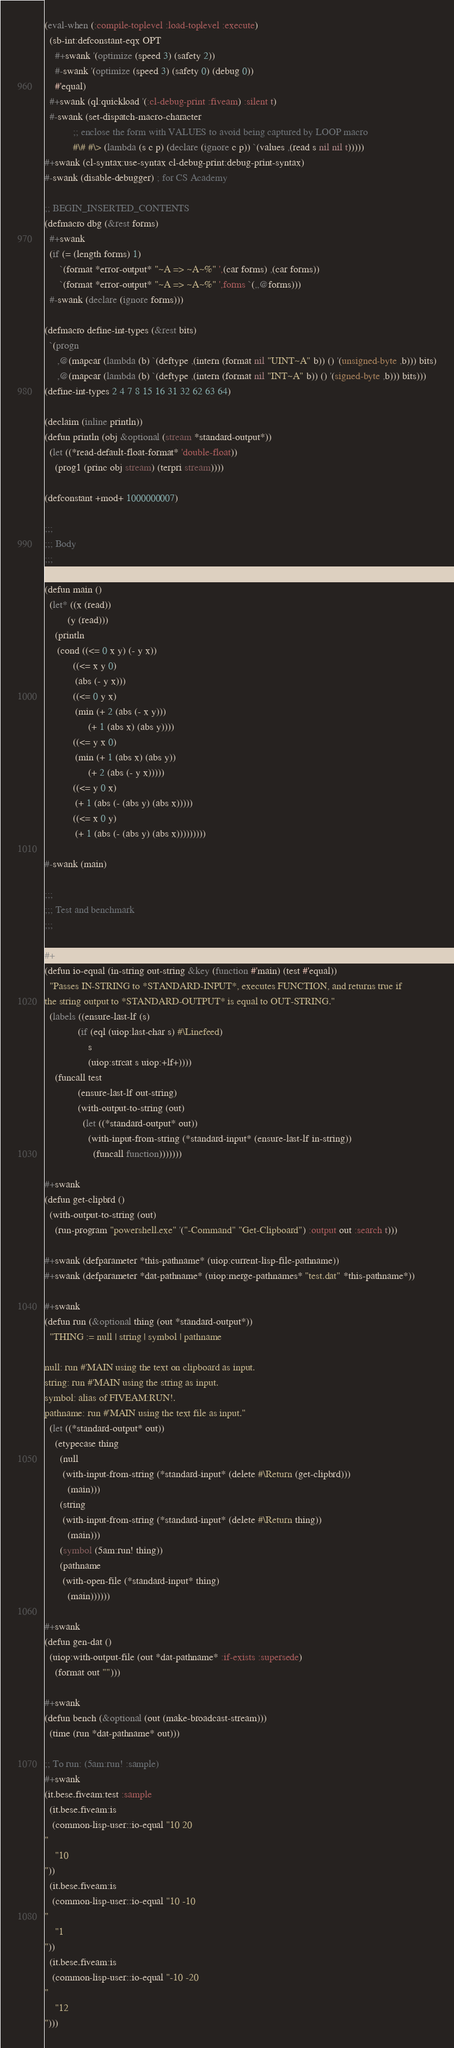<code> <loc_0><loc_0><loc_500><loc_500><_Lisp_>(eval-when (:compile-toplevel :load-toplevel :execute)
  (sb-int:defconstant-eqx OPT
    #+swank '(optimize (speed 3) (safety 2))
    #-swank '(optimize (speed 3) (safety 0) (debug 0))
    #'equal)
  #+swank (ql:quickload '(:cl-debug-print :fiveam) :silent t)
  #-swank (set-dispatch-macro-character
           ;; enclose the form with VALUES to avoid being captured by LOOP macro
           #\# #\> (lambda (s c p) (declare (ignore c p)) `(values ,(read s nil nil t)))))
#+swank (cl-syntax:use-syntax cl-debug-print:debug-print-syntax)
#-swank (disable-debugger) ; for CS Academy

;; BEGIN_INSERTED_CONTENTS
(defmacro dbg (&rest forms)
  #+swank
  (if (= (length forms) 1)
      `(format *error-output* "~A => ~A~%" ',(car forms) ,(car forms))
      `(format *error-output* "~A => ~A~%" ',forms `(,,@forms)))
  #-swank (declare (ignore forms)))

(defmacro define-int-types (&rest bits)
  `(progn
     ,@(mapcar (lambda (b) `(deftype ,(intern (format nil "UINT~A" b)) () '(unsigned-byte ,b))) bits)
     ,@(mapcar (lambda (b) `(deftype ,(intern (format nil "INT~A" b)) () '(signed-byte ,b))) bits)))
(define-int-types 2 4 7 8 15 16 31 32 62 63 64)

(declaim (inline println))
(defun println (obj &optional (stream *standard-output*))
  (let ((*read-default-float-format* 'double-float))
    (prog1 (princ obj stream) (terpri stream))))

(defconstant +mod+ 1000000007)

;;;
;;; Body
;;;

(defun main ()
  (let* ((x (read))
         (y (read)))
    (println
     (cond ((<= 0 x y) (- y x))
           ((<= x y 0)
            (abs (- y x)))
           ((<= 0 y x)
            (min (+ 2 (abs (- x y)))
                 (+ 1 (abs x) (abs y))))
           ((<= y x 0)
            (min (+ 1 (abs x) (abs y))
                 (+ 2 (abs (- y x)))))
           ((<= y 0 x)
            (+ 1 (abs (- (abs y) (abs x)))))
           ((<= x 0 y)
            (+ 1 (abs (- (abs y) (abs x)))))))))

#-swank (main)

;;;
;;; Test and benchmark
;;;

#+swank
(defun io-equal (in-string out-string &key (function #'main) (test #'equal))
  "Passes IN-STRING to *STANDARD-INPUT*, executes FUNCTION, and returns true if
the string output to *STANDARD-OUTPUT* is equal to OUT-STRING."
  (labels ((ensure-last-lf (s)
             (if (eql (uiop:last-char s) #\Linefeed)
                 s
                 (uiop:strcat s uiop:+lf+))))
    (funcall test
             (ensure-last-lf out-string)
             (with-output-to-string (out)
               (let ((*standard-output* out))
                 (with-input-from-string (*standard-input* (ensure-last-lf in-string))
                   (funcall function)))))))

#+swank
(defun get-clipbrd ()
  (with-output-to-string (out)
    (run-program "powershell.exe" '("-Command" "Get-Clipboard") :output out :search t)))

#+swank (defparameter *this-pathname* (uiop:current-lisp-file-pathname))
#+swank (defparameter *dat-pathname* (uiop:merge-pathnames* "test.dat" *this-pathname*))

#+swank
(defun run (&optional thing (out *standard-output*))
  "THING := null | string | symbol | pathname

null: run #'MAIN using the text on clipboard as input.
string: run #'MAIN using the string as input.
symbol: alias of FIVEAM:RUN!.
pathname: run #'MAIN using the text file as input."
  (let ((*standard-output* out))
    (etypecase thing
      (null
       (with-input-from-string (*standard-input* (delete #\Return (get-clipbrd)))
         (main)))
      (string
       (with-input-from-string (*standard-input* (delete #\Return thing))
         (main)))
      (symbol (5am:run! thing))
      (pathname
       (with-open-file (*standard-input* thing)
         (main))))))

#+swank
(defun gen-dat ()
  (uiop:with-output-file (out *dat-pathname* :if-exists :supersede)
    (format out "")))

#+swank
(defun bench (&optional (out (make-broadcast-stream)))
  (time (run *dat-pathname* out)))

;; To run: (5am:run! :sample)
#+swank
(it.bese.fiveam:test :sample
  (it.bese.fiveam:is
   (common-lisp-user::io-equal "10 20
"
    "10
"))
  (it.bese.fiveam:is
   (common-lisp-user::io-equal "10 -10
"
    "1
"))
  (it.bese.fiveam:is
   (common-lisp-user::io-equal "-10 -20
"
    "12
")))
</code> 